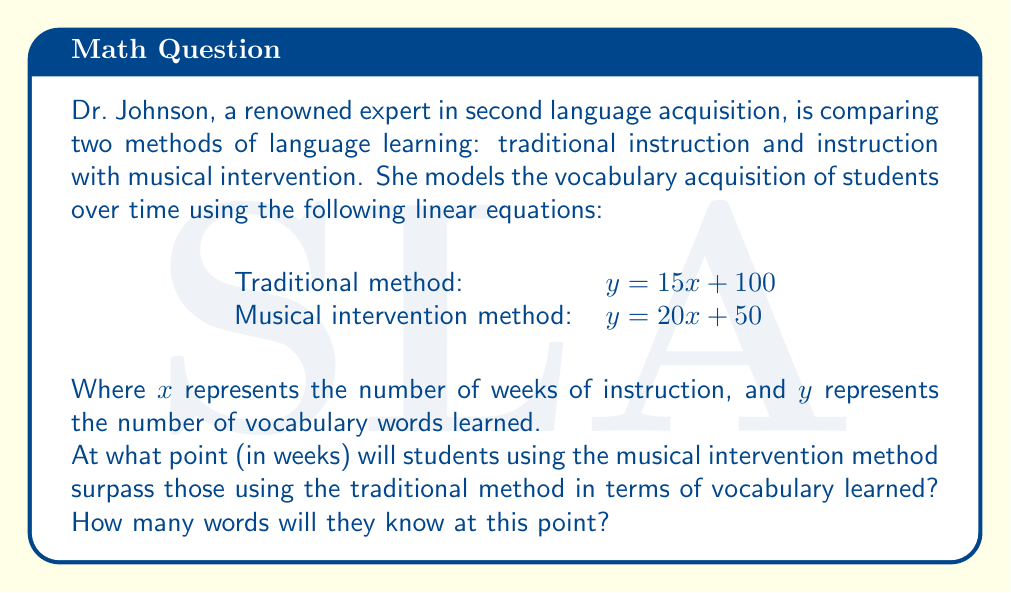What is the answer to this math problem? To solve this problem, we need to find the intersection point of the two linear equations. This point represents when the two methods yield the same number of vocabulary words learned.

Let's set up the system of equations:

$$\begin{cases}
y = 15x + 100 & \text{(Traditional method)} \\
y = 20x + 50 & \text{(Musical intervention method)}
\end{cases}$$

To find the intersection point, we set these equations equal to each other:

$$15x + 100 = 20x + 50$$

Now, let's solve for $x$:

1) Subtract $15x$ from both sides:
   $100 = 5x + 50$

2) Subtract 50 from both sides:
   $50 = 5x$

3) Divide both sides by 5:
   $10 = x$

So, the methods intersect at $x = 10$ weeks.

To find the number of words learned at this point, we can substitute $x = 10$ into either equation. Let's use the traditional method equation:

$y = 15(10) + 100 = 150 + 100 = 250$

Therefore, after 10 weeks, students in both methods will have learned 250 words.

[asy]
import graph;
size(200,200);
real f(real x) {return 15x + 100;}
real g(real x) {return 20x + 50;}
xaxis("Weeks",axis=BottomTop,Ticks);
yaxis("Words Learned",axis=LeftRight,Ticks);
draw(graph(f,0,15),blue);
draw(graph(g,0,15),red);
dot((10,250));
label("(10, 250)",(10,250),NE);
label("Traditional",graph(f,14,15),E,blue);
label("Musical",graph(g,14,15),E,red);
[/asy]
Answer: The musical intervention method will surpass the traditional method after 10 weeks, at which point students will have learned 250 vocabulary words. 